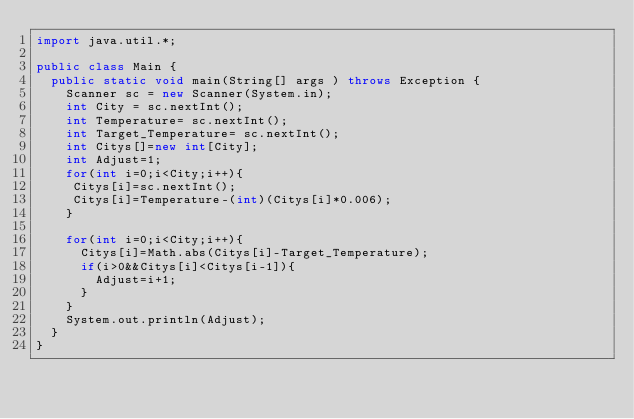<code> <loc_0><loc_0><loc_500><loc_500><_Java_>import java.util.*;

public class Main {
  public static void main(String[] args ) throws Exception {
    Scanner sc = new Scanner(System.in);
    int City = sc.nextInt();
    int Temperature= sc.nextInt();
    int Target_Temperature= sc.nextInt();
    int Citys[]=new int[City];
    int Adjust=1;
    for(int i=0;i<City;i++){
     Citys[i]=sc.nextInt();
     Citys[i]=Temperature-(int)(Citys[i]*0.006);
    }
    
    for(int i=0;i<City;i++){
      Citys[i]=Math.abs(Citys[i]-Target_Temperature);
      if(i>0&&Citys[i]<Citys[i-1]){
      	Adjust=i+1;
      }
    }
    System.out.println(Adjust);
  }
}</code> 